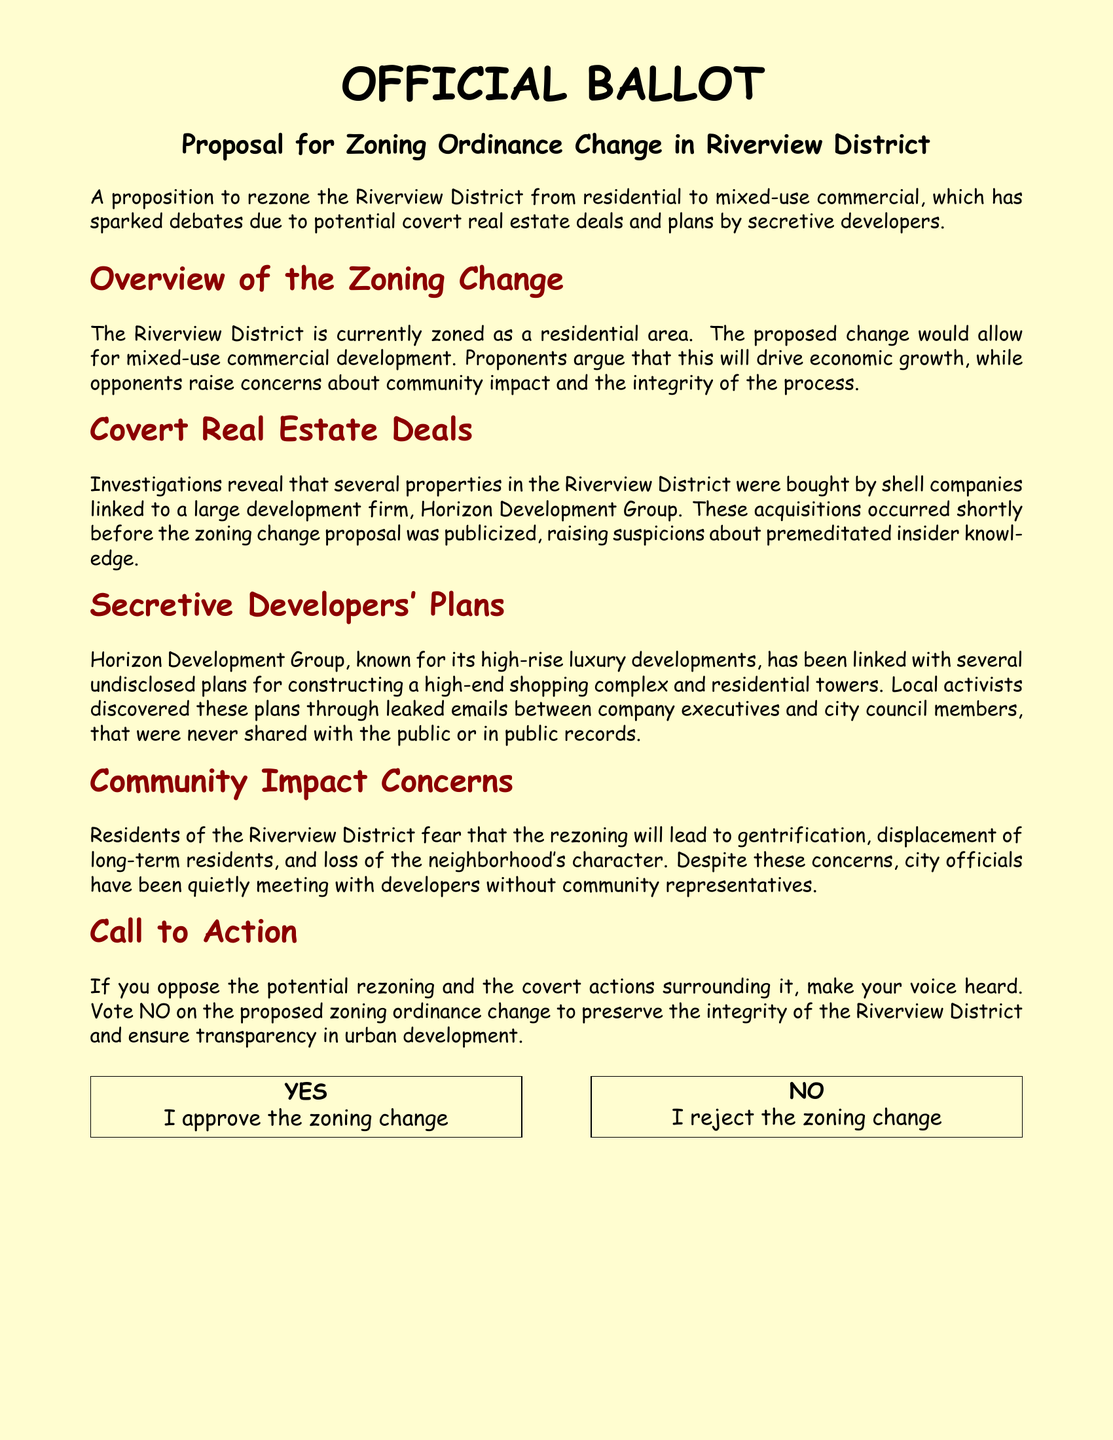What is the proposed zoning change for the Riverview District? The proposed zoning change is to rezone from residential to mixed-use commercial.
Answer: mixed-use commercial Which company is linked to covert real estate deals in the Riverview District? The company linked to covert real estate deals is Horizon Development Group.
Answer: Horizon Development Group What do local activists believe about the developers' plans? Local activists believe the plans were undisclosed and revealed through leaked emails.
Answer: undisclosed What concerns do residents have regarding the zoning change? Residents fear that gentrification will lead to the displacement of long-term residents.
Answer: gentrification What action does the ballot encourage if someone opposes the zoning change? The ballot encourages voters to make their voice heard by voting NO.
Answer: vote NO 